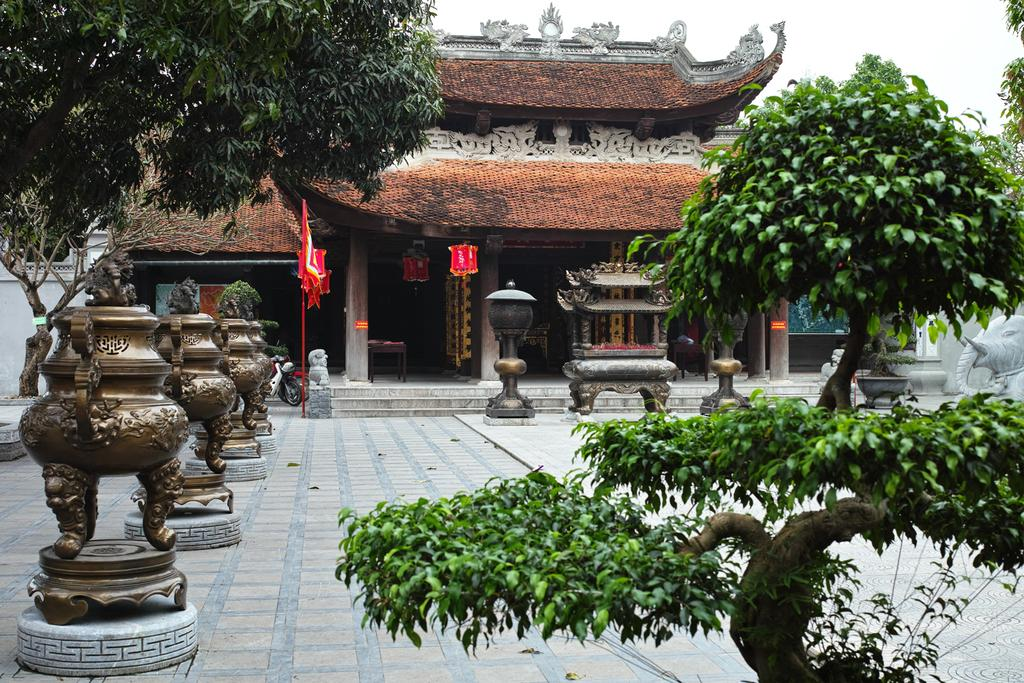What type of living organisms can be seen in the image? Plants can be seen in the image. What color are the plants in the image? The plants are green. What other objects can be seen in the image? There are posts, a flag, and a building in the image. What colors are the posts and the building? The posts are brown, and the building is brown. What color is the flag in the image? The flag is red. What part of the natural environment is visible in the image? The sky is visible in the image. What color is the sky in the image? The sky is white. Can you see a flock of birds flying over the building in the image? There is no mention of birds or a flock in the image, so we cannot confirm their presence. 